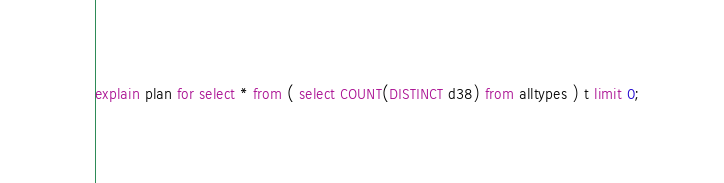<code> <loc_0><loc_0><loc_500><loc_500><_SQL_>explain plan for select * from ( select COUNT(DISTINCT d38) from alltypes ) t limit 0;
</code> 